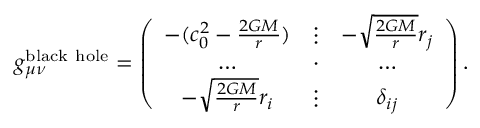<formula> <loc_0><loc_0><loc_500><loc_500>g _ { \mu \nu } ^ { b l a c k h o l e } = \left ( \begin{array} { c c c } { - ( c _ { 0 } ^ { 2 } - \frac { 2 G M } { r } ) } & { \vdots } & { - \sqrt { \frac { 2 G M } { r } } { r _ { j } } } \\ { \dots } & { \cdot } & { \dots } \\ { - \sqrt { \frac { 2 G M } { r } } { r _ { i } } } & { \vdots } & { \delta _ { i j } } \end{array} \right ) .</formula> 